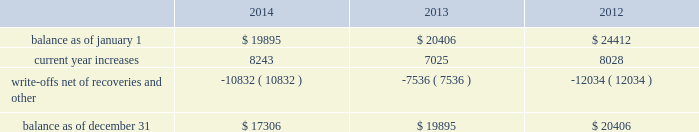American tower corporation and subsidiaries notes to consolidated financial statements financial statements include impairment of long-lived assets ( including goodwill ) , asset retirement obligations , revenue recognition , rent expense , stock-based compensation , income taxes and accounting for business combinations .
The company considers events or transactions that occur after the balance sheet date but before the financial statements are issued as additional evidence for certain estimates or to identify matters that require additional disclosure .
Concentrations of credit risk 2014the company is subject to concentrations of credit risk related to its cash and cash equivalents , notes receivable , accounts receivable , deferred rent asset and derivative financial instruments .
The company mitigates its risk with respect to cash and cash equivalents and derivative financial instruments by maintaining its deposits and contracts at high quality financial institutions and monitoring the credit ratings of those institutions .
The company derives the largest portion of its revenues , corresponding accounts receivable and the related deferred rent asset from a relatively small number of tenants in the telecommunications industry , and approximately 56% ( 56 % ) of its current year revenues are derived from four tenants .
In addition , the company has concentrations of credit risk in certain geographic areas .
The company mitigates its concentrations of credit risk with respect to notes and trade receivables and the related deferred rent assets by actively monitoring the credit worthiness of its borrowers and tenants .
In recognizing customer revenue , the company must assess the collectibility of both the amounts billed and the portion recognized in advance of billing on a straight-line basis .
This assessment takes tenant credit risk and business and industry conditions into consideration to ultimately determine the collectibility of the amounts billed .
To the extent the amounts , based on management 2019s estimates , may not be collectible , recognition is deferred until such point as collectibility is determined to be reasonably assured .
Any amounts that were previously recognized as revenue and subsequently determined to be uncollectible are charged to bad debt expense included in selling , general , administrative and development expense in the accompanying consolidated statements of operations .
Accounts receivable is reported net of allowances for doubtful accounts related to estimated losses resulting from a tenant 2019s inability to make required payments and allowances for amounts invoiced whose collectibility is not reasonably assured .
These allowances are generally estimated based on payment patterns , days past due and collection history , and incorporate changes in economic conditions that may not be reflected in historical trends , such as tenants in bankruptcy , liquidation or reorganization .
Receivables are written-off against the allowances when they are determined to be uncollectible .
Such determination includes analysis and consideration of the particular conditions of the account .
Changes in the allowances were as follows for the years ended december 31 , ( in thousands ) : .
Functional currency 2014the functional currency of each of the company 2019s foreign operating subsidiaries is the respective local currency , except for costa rica , where the functional currency is the u.s .
Dollar .
All foreign currency assets and liabilities held by the subsidiaries are translated into u.s .
Dollars at the exchange rate in .
For the four largest tenants , what is the average % (  % ) of current year revenues that each represents? 
Computations: (56 / 4)
Answer: 14.0. 